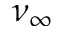Convert formula to latex. <formula><loc_0><loc_0><loc_500><loc_500>\nu _ { \infty }</formula> 